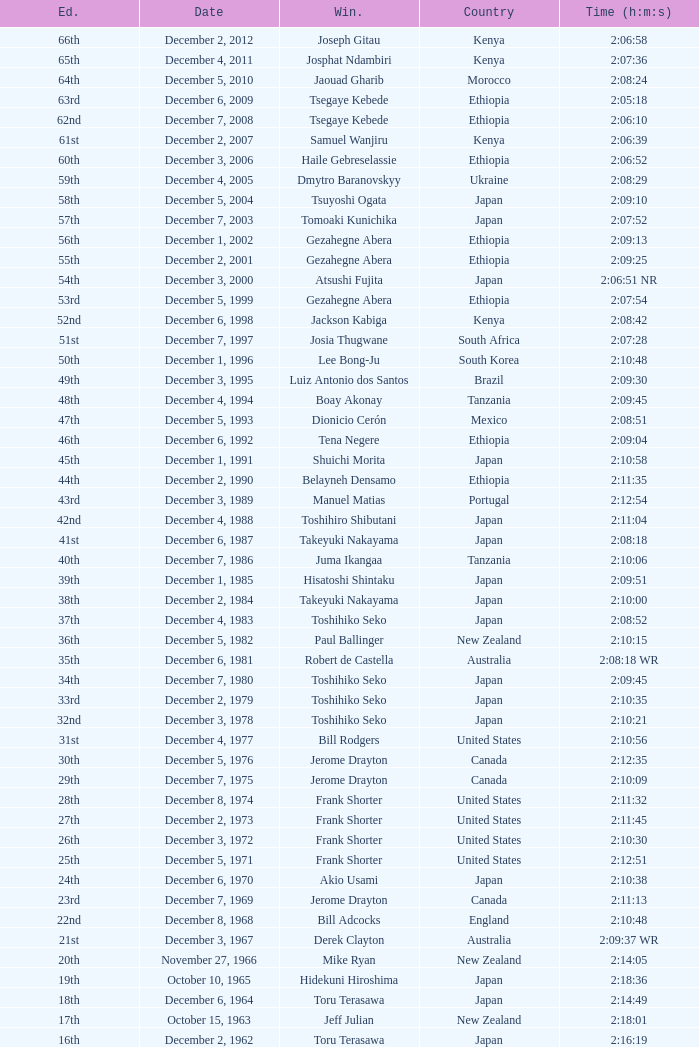On what date did Lee Bong-Ju win in 2:10:48? December 1, 1996. 